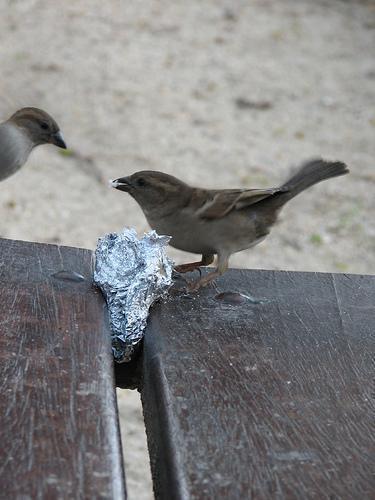What is tinfoil made of?
Indicate the correct response and explain using: 'Answer: answer
Rationale: rationale.'
Options: Tin, plastic, steel, copper. Answer: tin.
Rationale: Tinfoil is balled up in the street. 